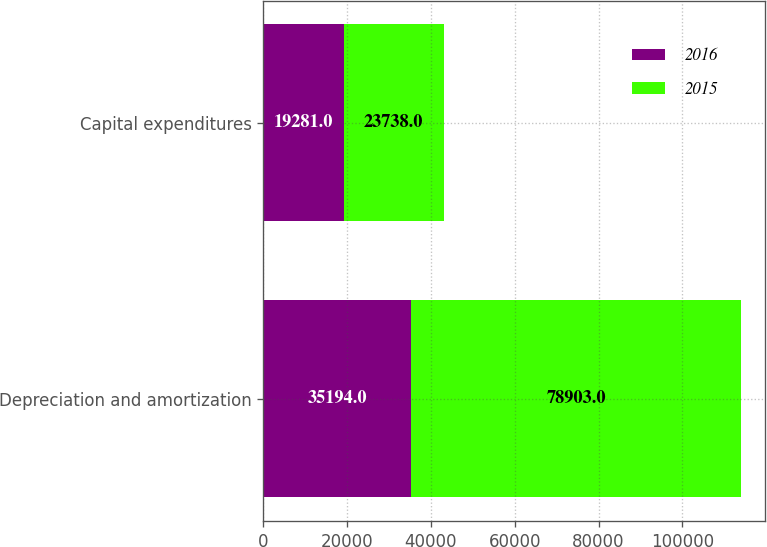Convert chart to OTSL. <chart><loc_0><loc_0><loc_500><loc_500><stacked_bar_chart><ecel><fcel>Depreciation and amortization<fcel>Capital expenditures<nl><fcel>2016<fcel>35194<fcel>19281<nl><fcel>2015<fcel>78903<fcel>23738<nl></chart> 